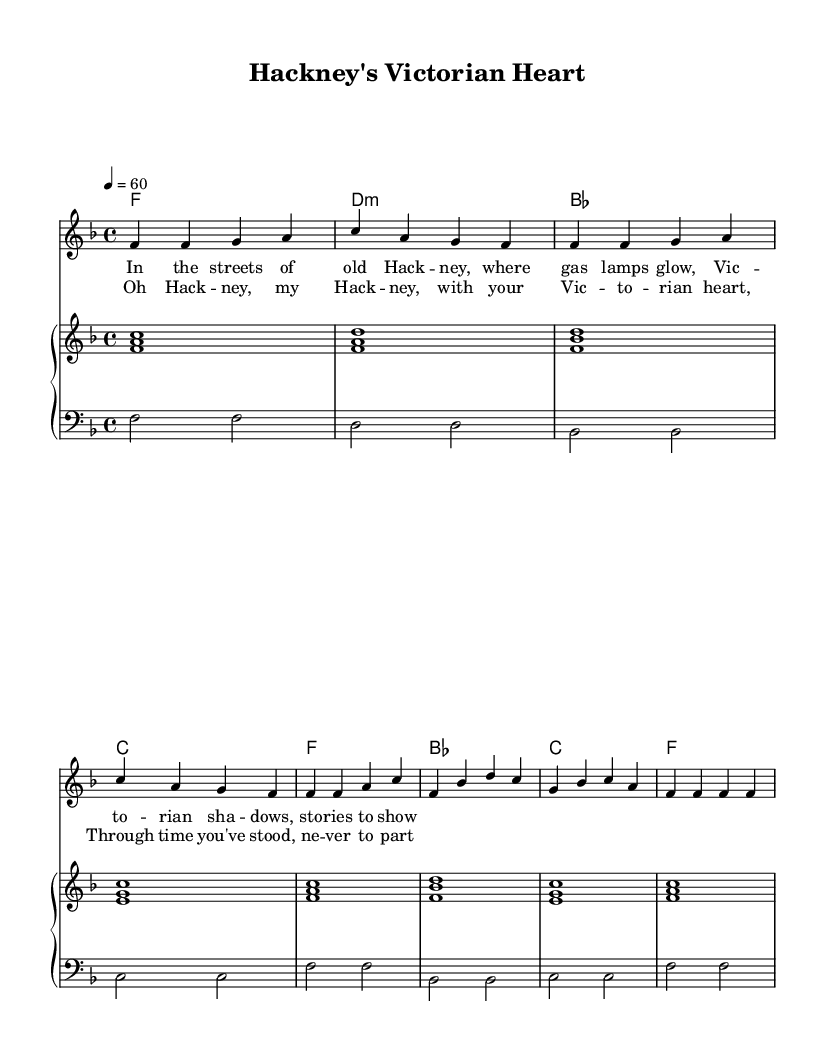What is the key signature of this music? The key signature is F major, which has one flat (B flat). You can identify this by looking at the key signature area at the beginning of the staff, which indicates the flat note.
Answer: F major What is the time signature of this music? The time signature is 4/4, indicated at the beginning of the score. This means there are four beats per measure, and the quarter note receives one beat.
Answer: 4/4 What is the tempo marking for this piece? The tempo marking is quarter note equals 60. This is indicated at the beginning of the score as a metronome marking, specifying the speed of the music.
Answer: 60 What type of song is this based on its structure? This song is a ballad. A ballad typically features a slow tempo, emotional lyrics, and a melodic structure with verses and choruses, which is evident in the sheet music.
Answer: Ballad How many measures are in the verse section? The verse section contains four measures. This is determined by counting the groupings of four beats represented in the melody and harmonies that correlate to the verse lyrics.
Answer: 4 What are the chord qualities used in this piece? The chords used include major and minor qualities. For example, F is a major chord, while D is a minor chord indicated in the harmonies. You identify chord qualities through the chord symbols and the nature of the notes in the chord.
Answer: Major and minor 